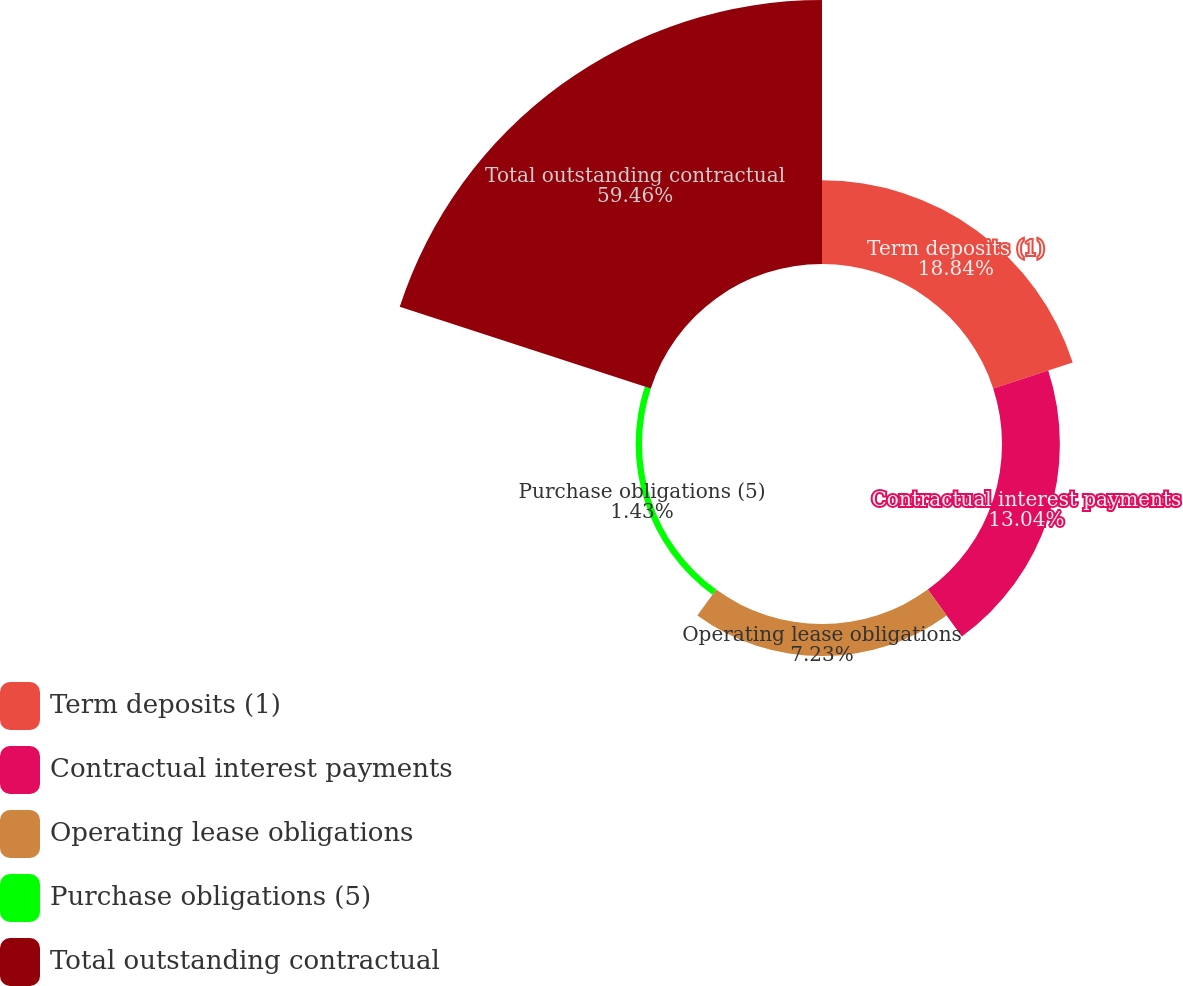Convert chart to OTSL. <chart><loc_0><loc_0><loc_500><loc_500><pie_chart><fcel>Term deposits (1)<fcel>Contractual interest payments<fcel>Operating lease obligations<fcel>Purchase obligations (5)<fcel>Total outstanding contractual<nl><fcel>18.84%<fcel>13.04%<fcel>7.23%<fcel>1.43%<fcel>59.47%<nl></chart> 